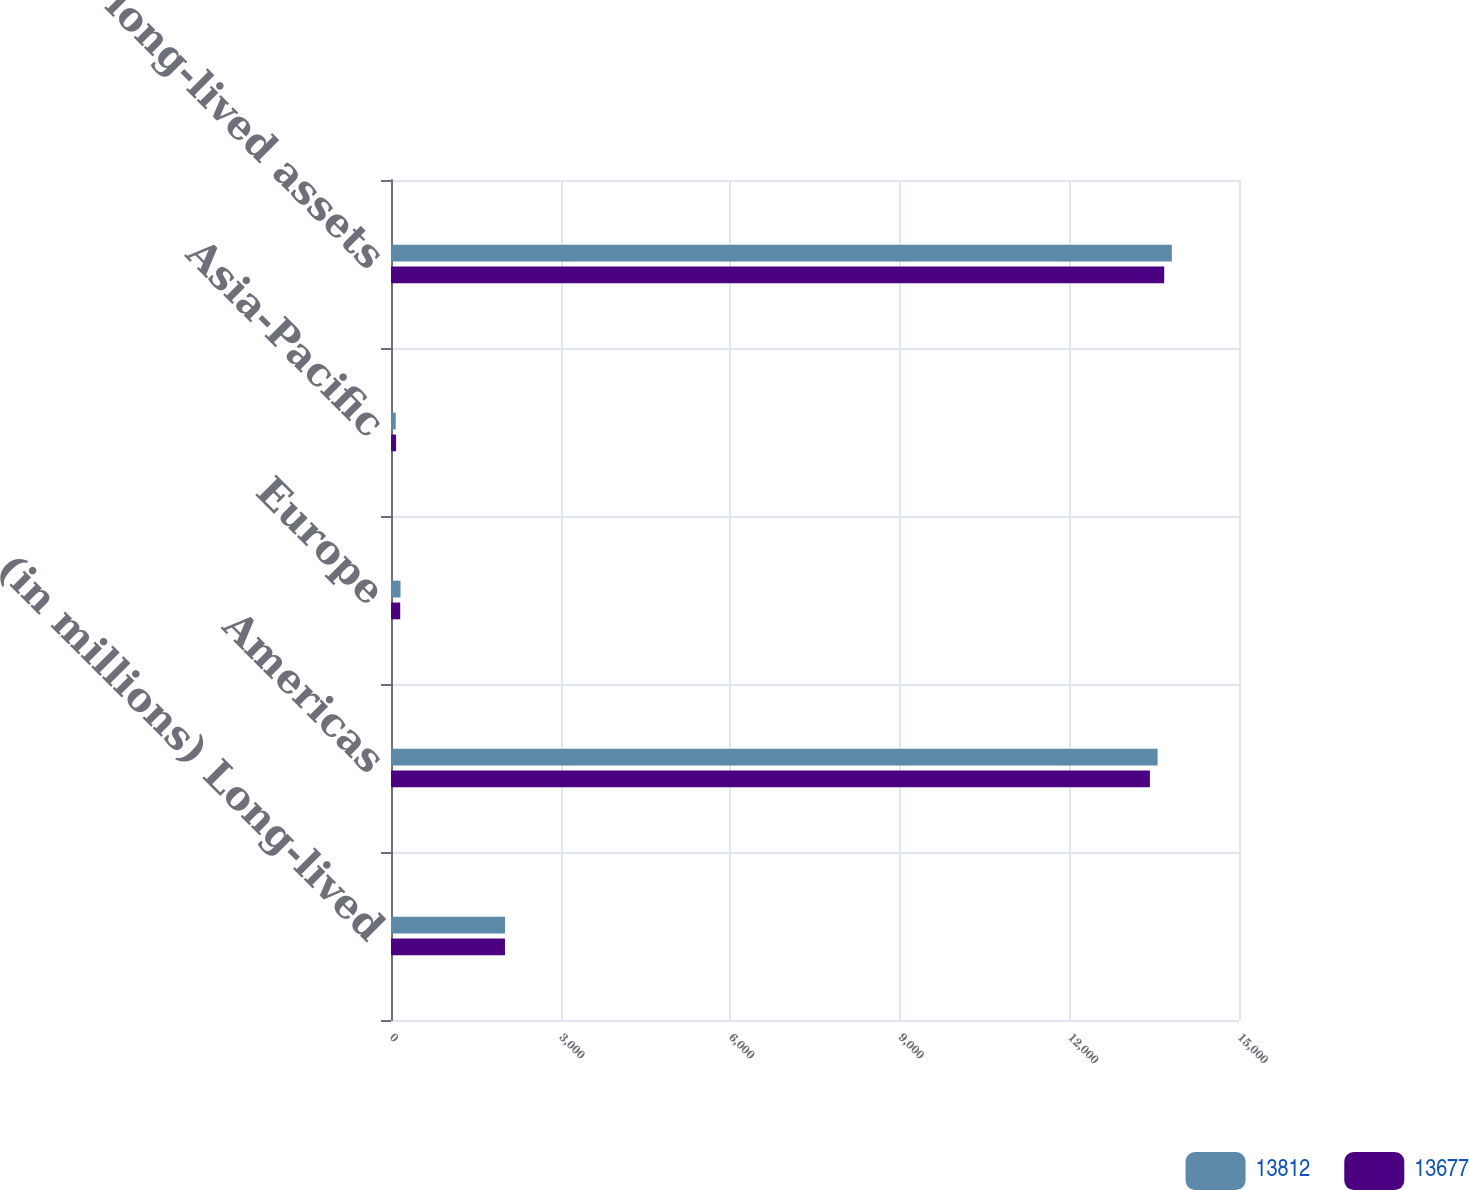Convert chart to OTSL. <chart><loc_0><loc_0><loc_500><loc_500><stacked_bar_chart><ecel><fcel>(in millions) Long-lived<fcel>Americas<fcel>Europe<fcel>Asia-Pacific<fcel>Total long-lived assets<nl><fcel>13812<fcel>2017<fcel>13560<fcel>168<fcel>84<fcel>13812<nl><fcel>13677<fcel>2016<fcel>13424<fcel>163<fcel>90<fcel>13677<nl></chart> 